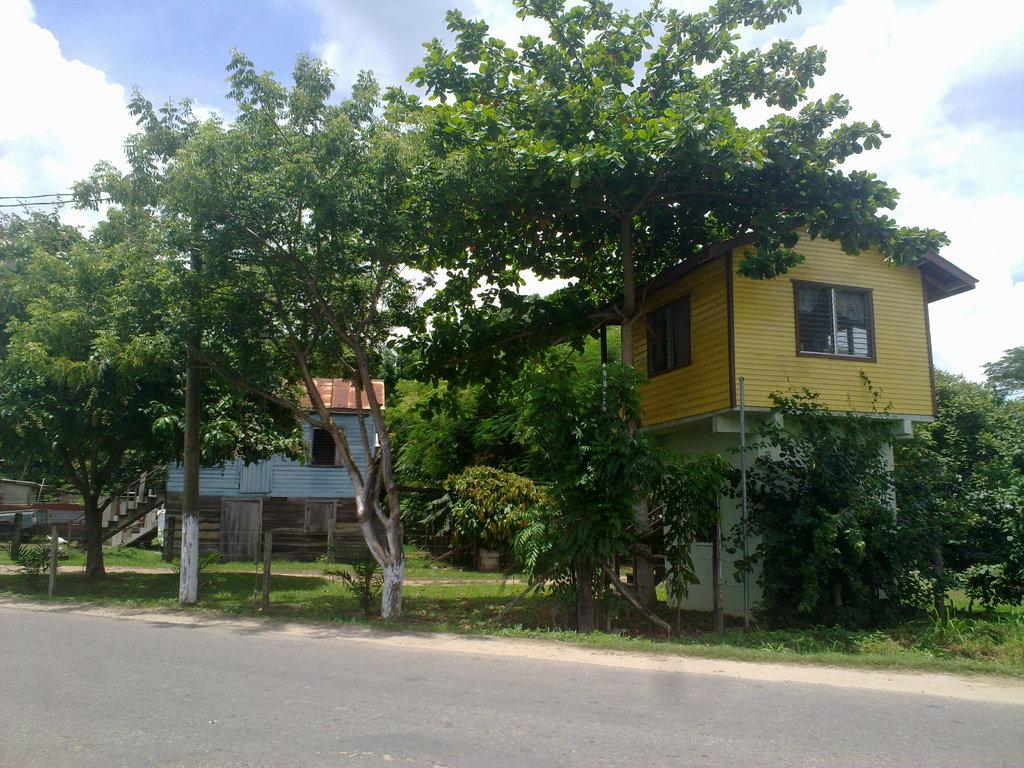What type of vegetation can be seen in the image? There is grass, plants, and trees in the image. What structures are present in the image? There are poles and houses in the image. What is on the road in the image? There is a vehicle on the road in the image. What part of the natural environment is visible in the image? The sky is visible in the image. Can you determine the time of day the image was taken? The image was likely taken during the day, as the sky is visible and there is no indication of darkness. What type of rhythm does the writer use in the image? There is no writer or rhythm present in the image; it features natural elements, structures, and a vehicle. 